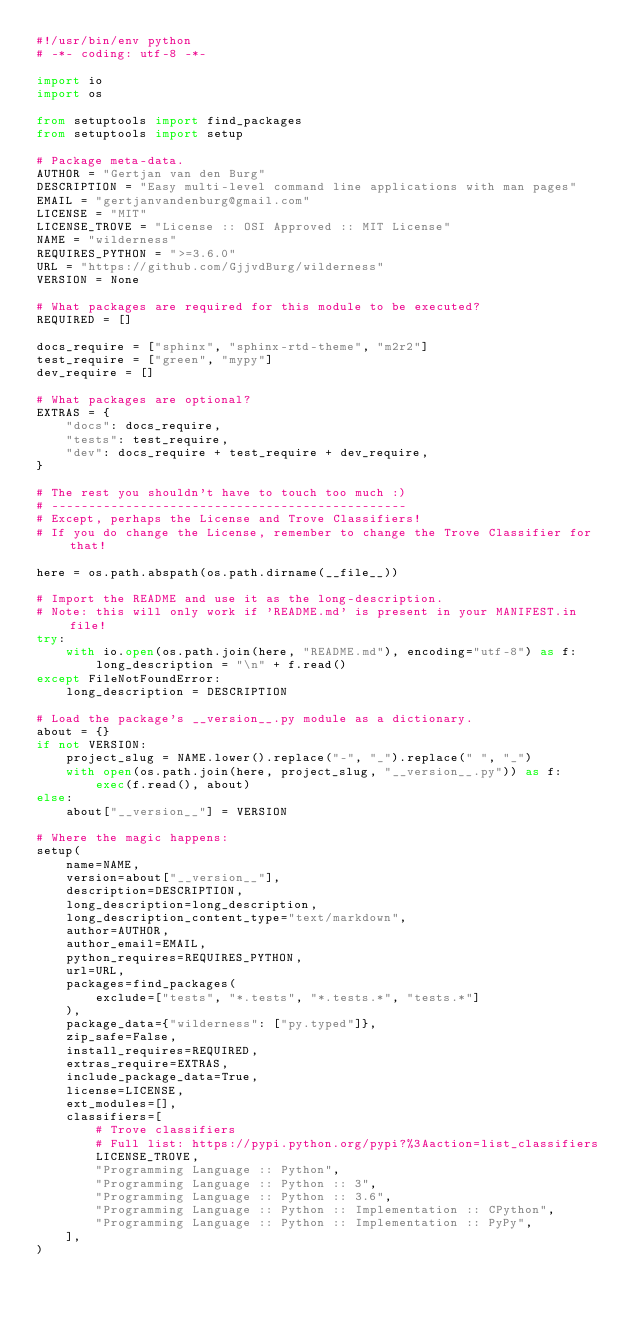<code> <loc_0><loc_0><loc_500><loc_500><_Python_>#!/usr/bin/env python
# -*- coding: utf-8 -*-

import io
import os

from setuptools import find_packages
from setuptools import setup

# Package meta-data.
AUTHOR = "Gertjan van den Burg"
DESCRIPTION = "Easy multi-level command line applications with man pages"
EMAIL = "gertjanvandenburg@gmail.com"
LICENSE = "MIT"
LICENSE_TROVE = "License :: OSI Approved :: MIT License"
NAME = "wilderness"
REQUIRES_PYTHON = ">=3.6.0"
URL = "https://github.com/GjjvdBurg/wilderness"
VERSION = None

# What packages are required for this module to be executed?
REQUIRED = []

docs_require = ["sphinx", "sphinx-rtd-theme", "m2r2"]
test_require = ["green", "mypy"]
dev_require = []

# What packages are optional?
EXTRAS = {
    "docs": docs_require,
    "tests": test_require,
    "dev": docs_require + test_require + dev_require,
}

# The rest you shouldn't have to touch too much :)
# ------------------------------------------------
# Except, perhaps the License and Trove Classifiers!
# If you do change the License, remember to change the Trove Classifier for that!

here = os.path.abspath(os.path.dirname(__file__))

# Import the README and use it as the long-description.
# Note: this will only work if 'README.md' is present in your MANIFEST.in file!
try:
    with io.open(os.path.join(here, "README.md"), encoding="utf-8") as f:
        long_description = "\n" + f.read()
except FileNotFoundError:
    long_description = DESCRIPTION

# Load the package's __version__.py module as a dictionary.
about = {}
if not VERSION:
    project_slug = NAME.lower().replace("-", "_").replace(" ", "_")
    with open(os.path.join(here, project_slug, "__version__.py")) as f:
        exec(f.read(), about)
else:
    about["__version__"] = VERSION

# Where the magic happens:
setup(
    name=NAME,
    version=about["__version__"],
    description=DESCRIPTION,
    long_description=long_description,
    long_description_content_type="text/markdown",
    author=AUTHOR,
    author_email=EMAIL,
    python_requires=REQUIRES_PYTHON,
    url=URL,
    packages=find_packages(
        exclude=["tests", "*.tests", "*.tests.*", "tests.*"]
    ),
    package_data={"wilderness": ["py.typed"]},
    zip_safe=False,
    install_requires=REQUIRED,
    extras_require=EXTRAS,
    include_package_data=True,
    license=LICENSE,
    ext_modules=[],
    classifiers=[
        # Trove classifiers
        # Full list: https://pypi.python.org/pypi?%3Aaction=list_classifiers
        LICENSE_TROVE,
        "Programming Language :: Python",
        "Programming Language :: Python :: 3",
        "Programming Language :: Python :: 3.6",
        "Programming Language :: Python :: Implementation :: CPython",
        "Programming Language :: Python :: Implementation :: PyPy",
    ],
)
</code> 